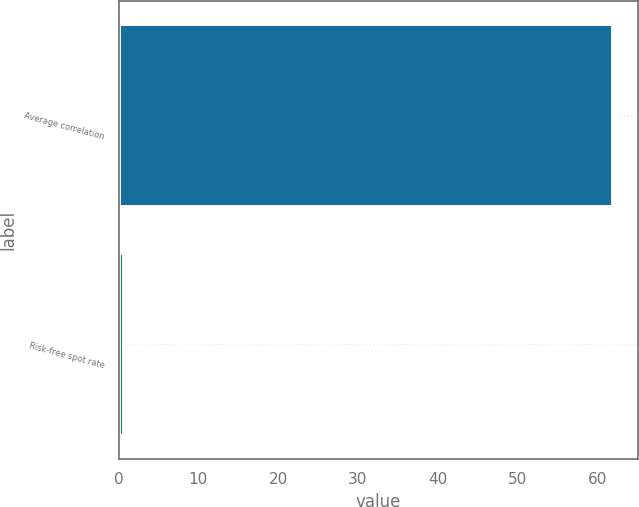<chart> <loc_0><loc_0><loc_500><loc_500><bar_chart><fcel>Average correlation<fcel>Risk-free spot rate<nl><fcel>62<fcel>0.7<nl></chart> 